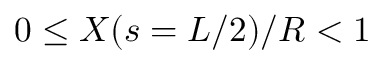Convert formula to latex. <formula><loc_0><loc_0><loc_500><loc_500>0 \leq X ( s = L / 2 ) / R < 1</formula> 